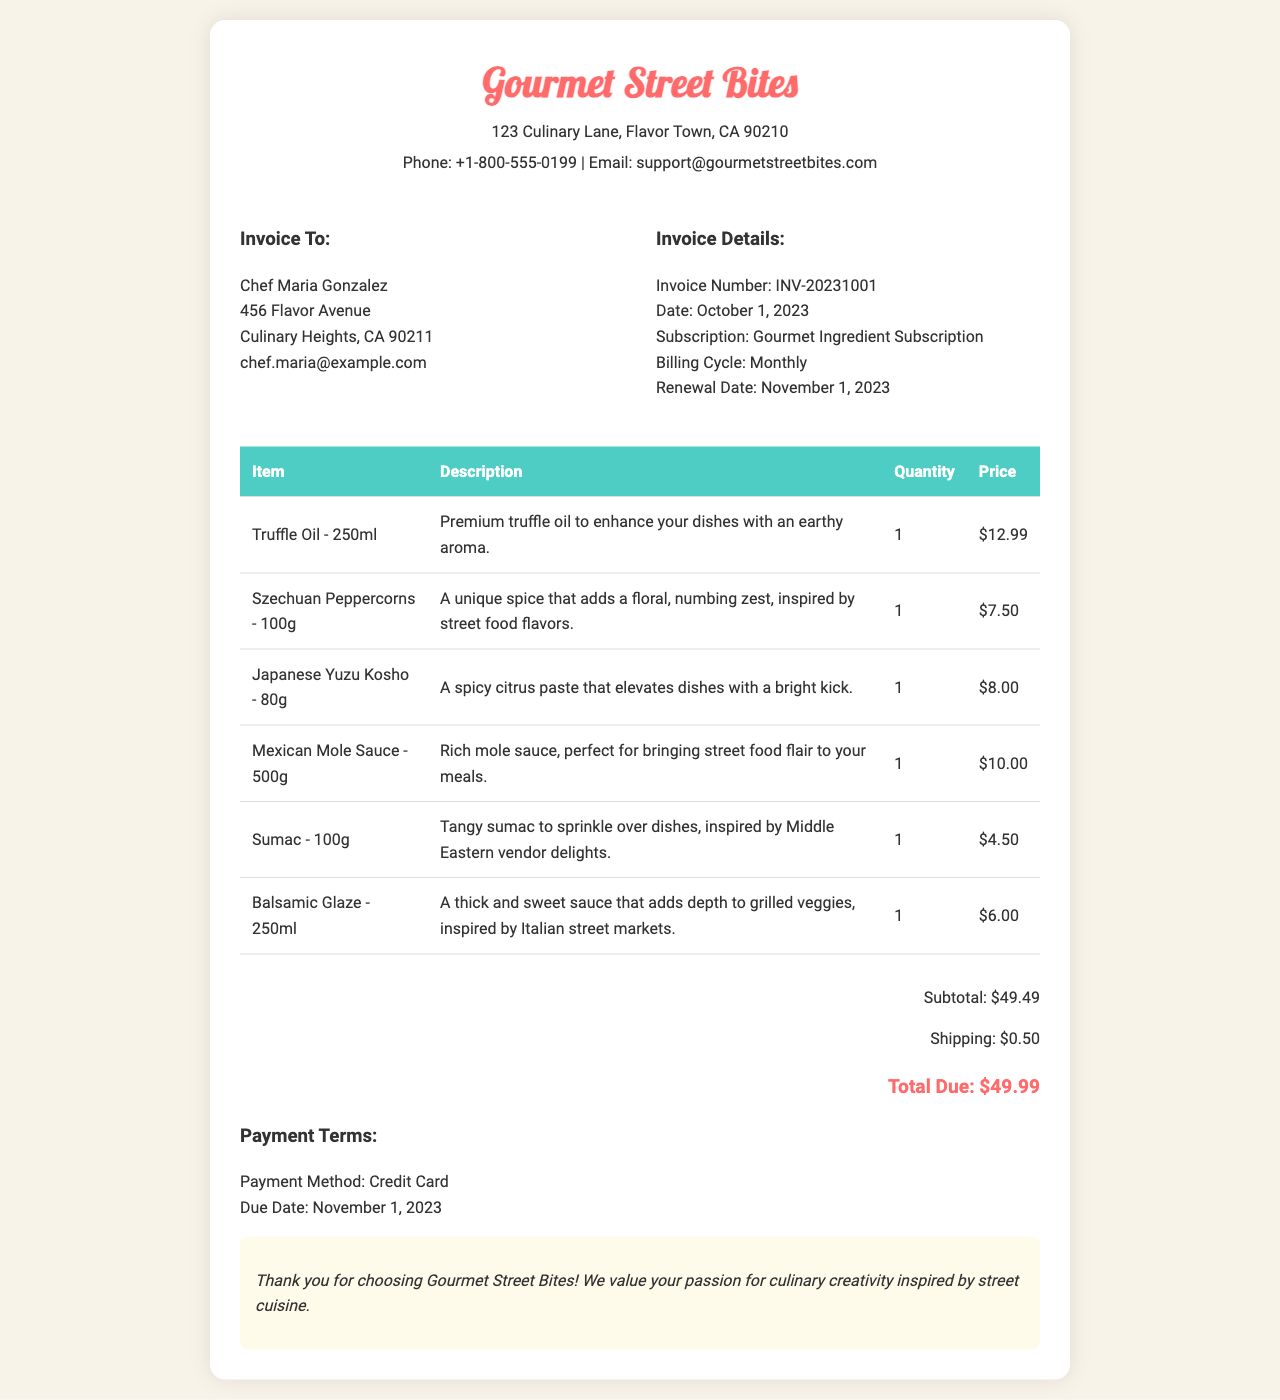What is the invoice number? The invoice number is found in the invoice details section as INV-20231001.
Answer: INV-20231001 What is the total amount due? The total amount due is located in the total summary section, indicated as $49.99.
Answer: $49.99 When is the renewal date? The renewal date is mentioned under the invoice details, which states November 1, 2023.
Answer: November 1, 2023 What is the quantity of Szechuan Peppercorns? The quantity of Szechuan Peppercorns is provided in the products table as 1.
Answer: 1 Which product is inspired by Middle Eastern vendor delights? The product inspired by Middle Eastern vendor delights is specified in the description of Sumac.
Answer: Sumac How many gourmet ingredients are listed? The total number of gourmet ingredients can be counted in the table, which includes 6 items.
Answer: 6 What is the shipping cost? The shipping cost is detailed in the total summary as $0.50.
Answer: $0.50 What payment method is used? The payment method can be found in the payment terms section, which lists Credit Card.
Answer: Credit Card What is the subtotal before shipping? The subtotal before shipping is mentioned in the total summary as $49.49.
Answer: $49.49 